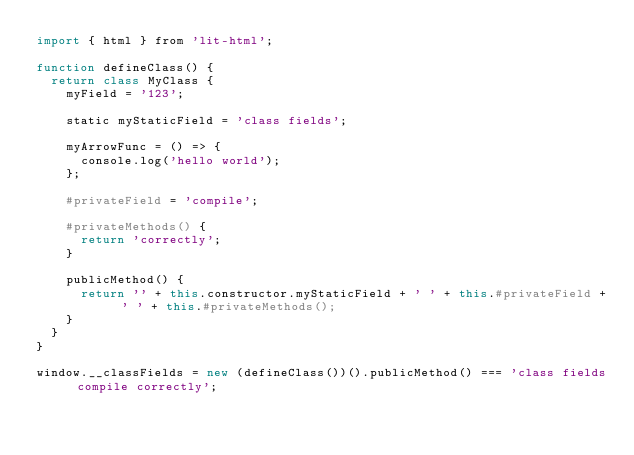<code> <loc_0><loc_0><loc_500><loc_500><_JavaScript_>import { html } from 'lit-html';

function defineClass() {
  return class MyClass {
    myField = '123';

    static myStaticField = 'class fields';

    myArrowFunc = () => {
      console.log('hello world');
    };

    #privateField = 'compile';

    #privateMethods() {
      return 'correctly';
    }

    publicMethod() {
      return '' + this.constructor.myStaticField + ' ' + this.#privateField + ' ' + this.#privateMethods();
    }
  }
}

window.__classFields = new (defineClass())().publicMethod() === 'class fields compile correctly';
</code> 